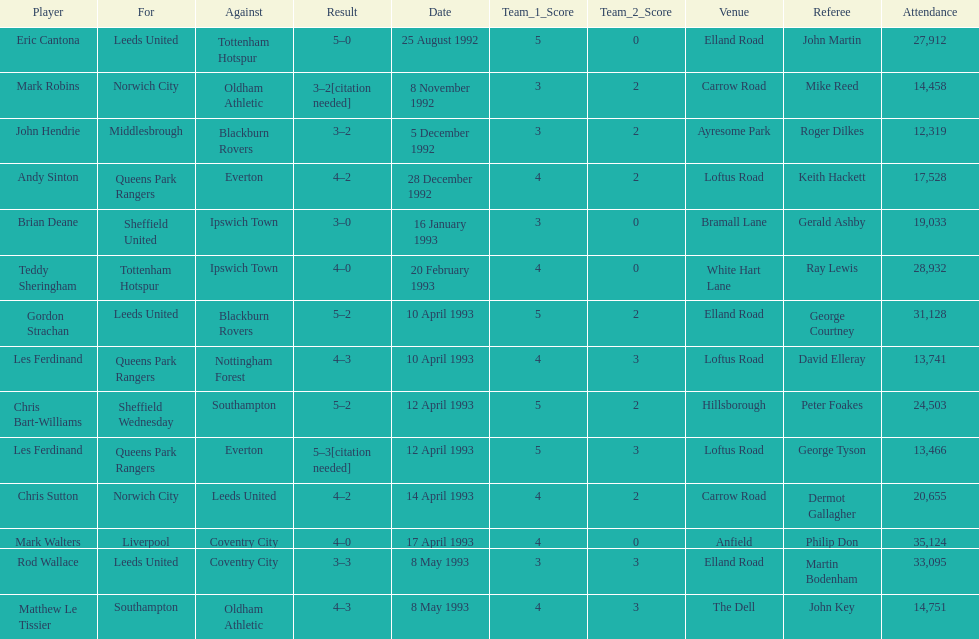Which team did liverpool play against? Coventry City. 